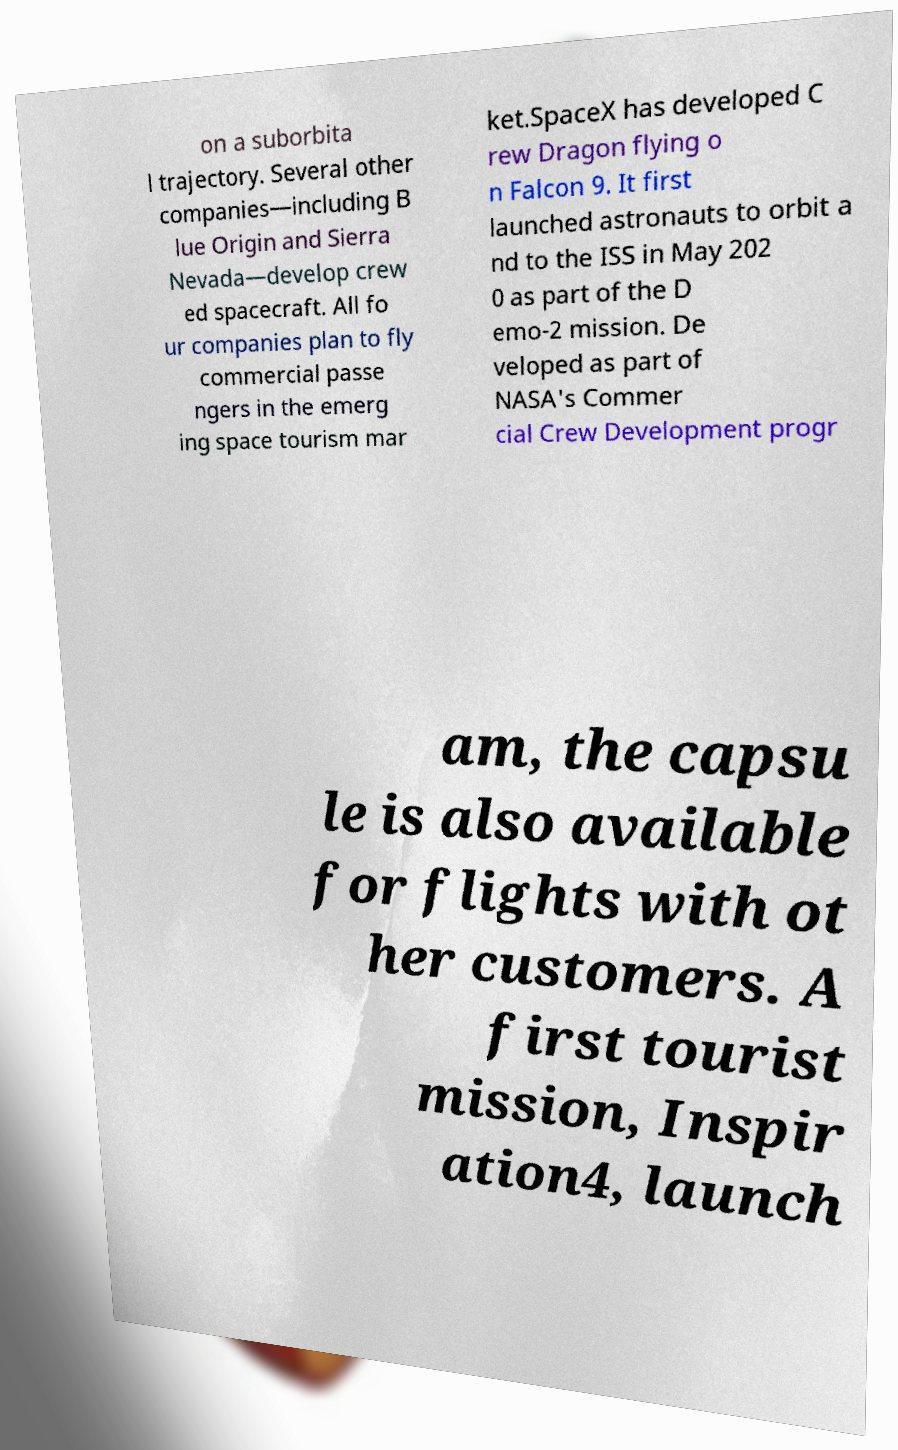For documentation purposes, I need the text within this image transcribed. Could you provide that? on a suborbita l trajectory. Several other companies—including B lue Origin and Sierra Nevada—develop crew ed spacecraft. All fo ur companies plan to fly commercial passe ngers in the emerg ing space tourism mar ket.SpaceX has developed C rew Dragon flying o n Falcon 9. It first launched astronauts to orbit a nd to the ISS in May 202 0 as part of the D emo-2 mission. De veloped as part of NASA's Commer cial Crew Development progr am, the capsu le is also available for flights with ot her customers. A first tourist mission, Inspir ation4, launch 